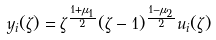<formula> <loc_0><loc_0><loc_500><loc_500>y _ { i } ( \zeta ) = \zeta ^ { \frac { 1 + \mu _ { 1 } } { 2 } } ( \zeta - 1 ) ^ { \frac { 1 - \mu _ { 2 } } { 2 } } u _ { i } ( \zeta )</formula> 